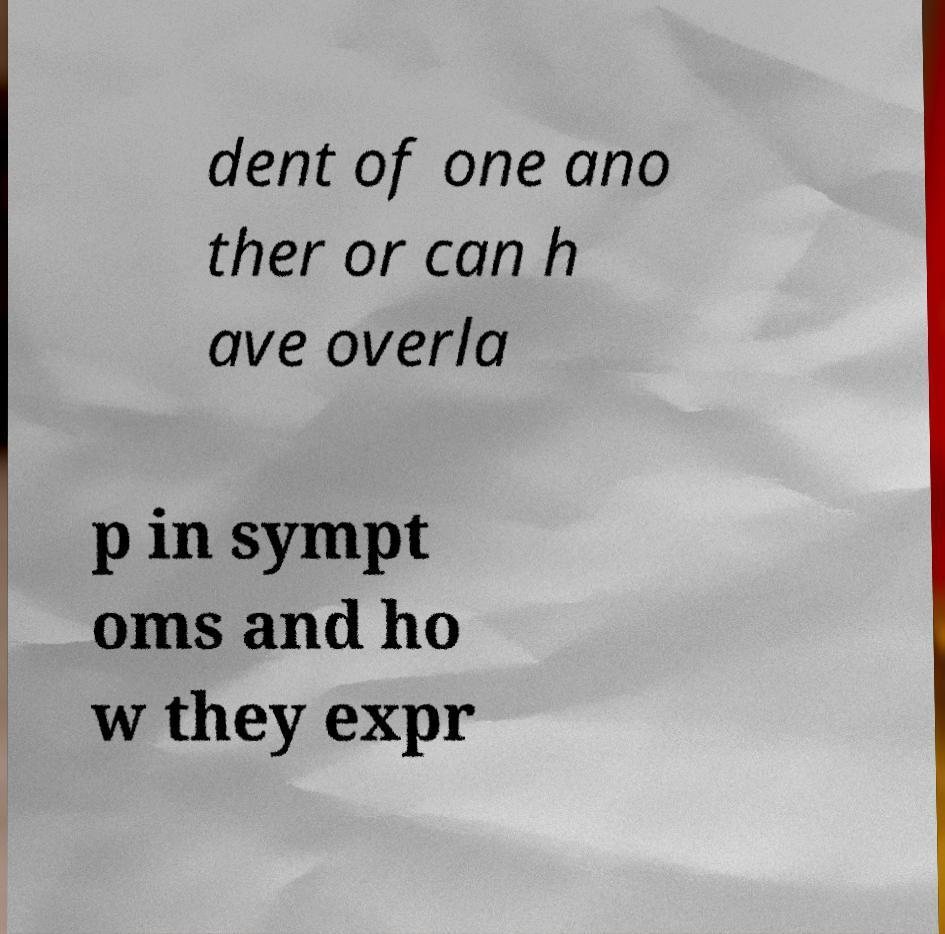I need the written content from this picture converted into text. Can you do that? dent of one ano ther or can h ave overla p in sympt oms and ho w they expr 